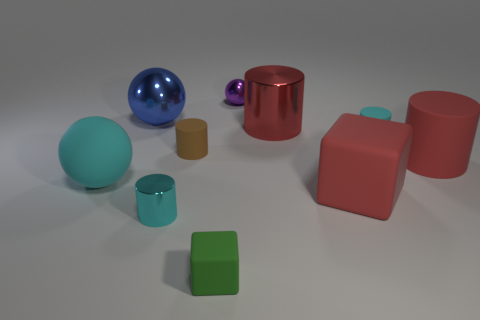Subtract all brown cylinders. How many cylinders are left? 4 Subtract all big red matte cylinders. How many cylinders are left? 4 Subtract all blue cylinders. Subtract all green spheres. How many cylinders are left? 5 Subtract all blocks. How many objects are left? 8 Subtract 0 blue cylinders. How many objects are left? 10 Subtract all large gray rubber objects. Subtract all tiny matte cubes. How many objects are left? 9 Add 7 red matte things. How many red matte things are left? 9 Add 5 metal objects. How many metal objects exist? 9 